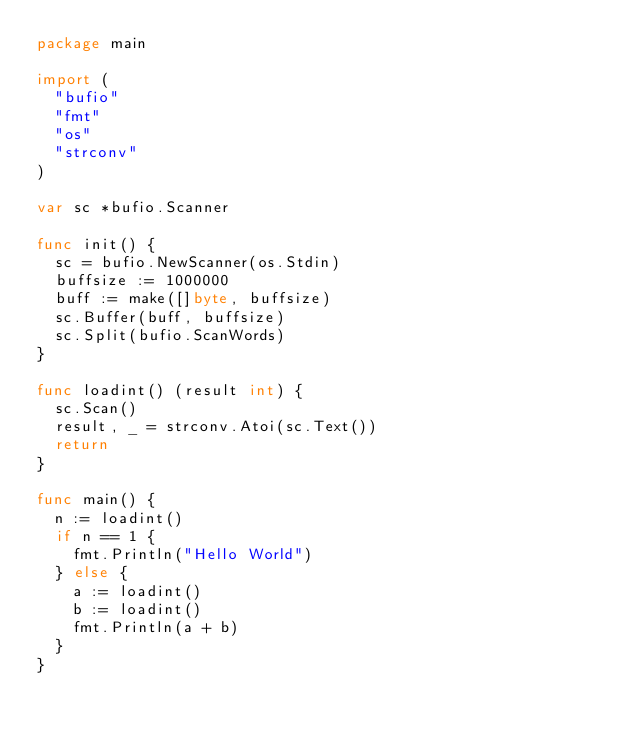<code> <loc_0><loc_0><loc_500><loc_500><_Go_>package main

import (
	"bufio"
	"fmt"
	"os"
	"strconv"
)

var sc *bufio.Scanner

func init() {
	sc = bufio.NewScanner(os.Stdin)
	buffsize := 1000000
	buff := make([]byte, buffsize)
	sc.Buffer(buff, buffsize)
	sc.Split(bufio.ScanWords)
}

func loadint() (result int) {
	sc.Scan()
	result, _ = strconv.Atoi(sc.Text())
	return
}

func main() {
	n := loadint()
	if n == 1 {
		fmt.Println("Hello World")
	} else {
		a := loadint()
		b := loadint()
		fmt.Println(a + b)
	}
}
</code> 